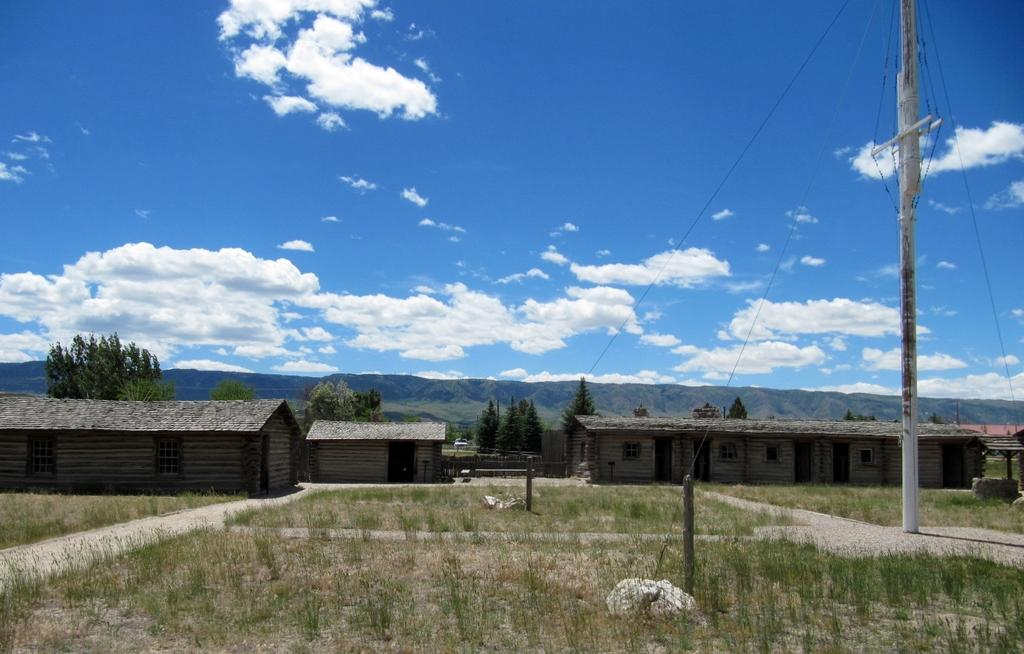What type of structures can be seen in the image? There are houses in the image. What type of vegetation is present in the image? There is grass and trees in the image. What can be found on the right side of the image? There is a pole with ropes on the right side of the image. What is visible in the background of the image? There are hills and the sky in the background of the image. Can you tell me how many sons are visible in the image? There is no son present in the image. What type of mailbox is located near the trees in the image? There is no mailbox present in the image. 